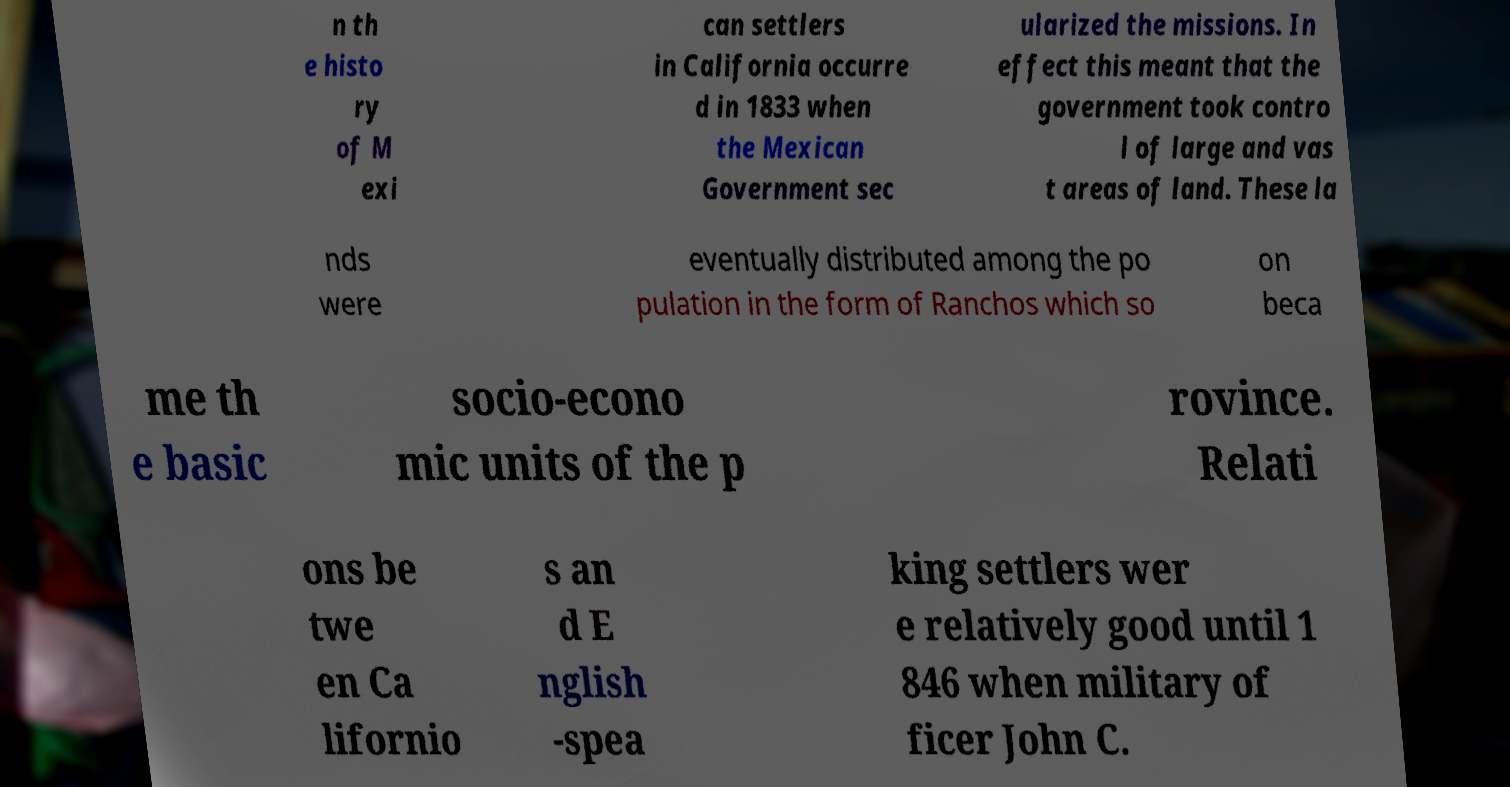Can you accurately transcribe the text from the provided image for me? n th e histo ry of M exi can settlers in California occurre d in 1833 when the Mexican Government sec ularized the missions. In effect this meant that the government took contro l of large and vas t areas of land. These la nds were eventually distributed among the po pulation in the form of Ranchos which so on beca me th e basic socio-econo mic units of the p rovince. Relati ons be twe en Ca lifornio s an d E nglish -spea king settlers wer e relatively good until 1 846 when military of ficer John C. 